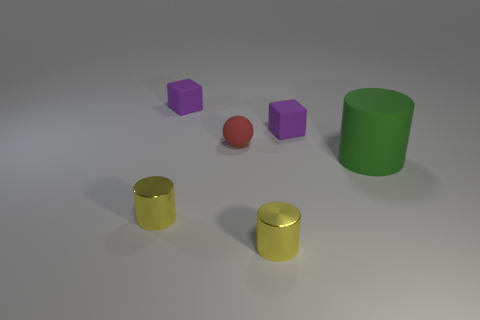Add 4 small blue shiny cylinders. How many objects exist? 10 Subtract all balls. How many objects are left? 5 Subtract all matte cubes. Subtract all small yellow shiny things. How many objects are left? 2 Add 2 tiny matte spheres. How many tiny matte spheres are left? 3 Add 2 rubber blocks. How many rubber blocks exist? 4 Subtract 0 gray cubes. How many objects are left? 6 